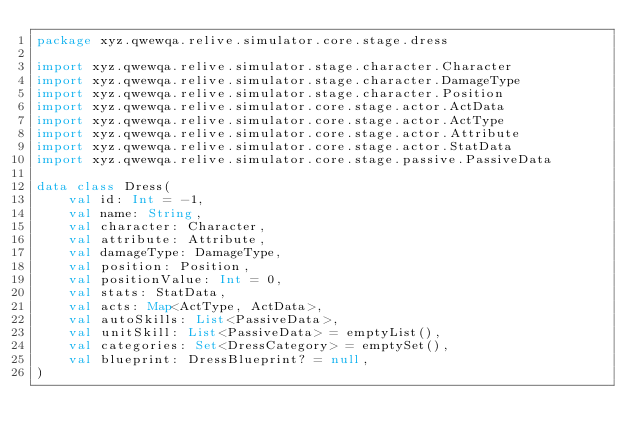<code> <loc_0><loc_0><loc_500><loc_500><_Kotlin_>package xyz.qwewqa.relive.simulator.core.stage.dress

import xyz.qwewqa.relive.simulator.stage.character.Character
import xyz.qwewqa.relive.simulator.stage.character.DamageType
import xyz.qwewqa.relive.simulator.stage.character.Position
import xyz.qwewqa.relive.simulator.core.stage.actor.ActData
import xyz.qwewqa.relive.simulator.core.stage.actor.ActType
import xyz.qwewqa.relive.simulator.core.stage.actor.Attribute
import xyz.qwewqa.relive.simulator.core.stage.actor.StatData
import xyz.qwewqa.relive.simulator.core.stage.passive.PassiveData

data class Dress(
    val id: Int = -1,
    val name: String,
    val character: Character,
    val attribute: Attribute,
    val damageType: DamageType,
    val position: Position,
    val positionValue: Int = 0,
    val stats: StatData,
    val acts: Map<ActType, ActData>,
    val autoSkills: List<PassiveData>,
    val unitSkill: List<PassiveData> = emptyList(),
    val categories: Set<DressCategory> = emptySet(),
    val blueprint: DressBlueprint? = null,
)</code> 